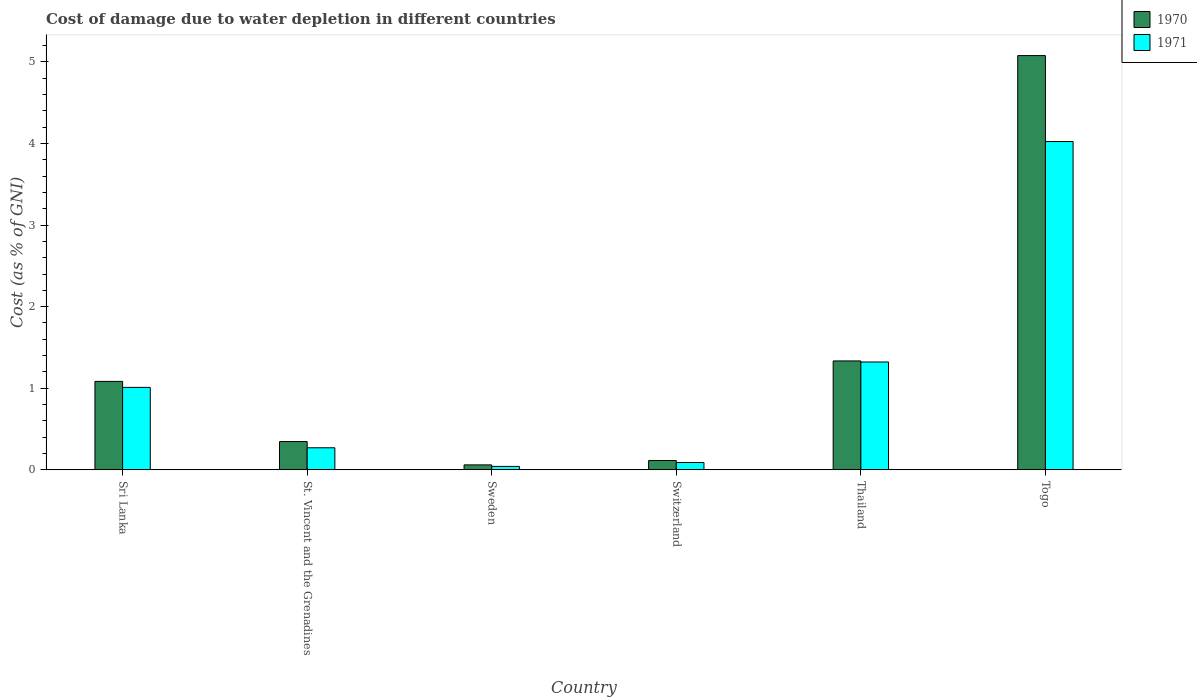Are the number of bars per tick equal to the number of legend labels?
Provide a short and direct response. Yes. Are the number of bars on each tick of the X-axis equal?
Ensure brevity in your answer.  Yes. What is the label of the 2nd group of bars from the left?
Your answer should be very brief. St. Vincent and the Grenadines. In how many cases, is the number of bars for a given country not equal to the number of legend labels?
Your answer should be compact. 0. What is the cost of damage caused due to water depletion in 1971 in St. Vincent and the Grenadines?
Offer a very short reply. 0.27. Across all countries, what is the maximum cost of damage caused due to water depletion in 1970?
Your response must be concise. 5.08. Across all countries, what is the minimum cost of damage caused due to water depletion in 1970?
Your answer should be very brief. 0.06. In which country was the cost of damage caused due to water depletion in 1971 maximum?
Keep it short and to the point. Togo. In which country was the cost of damage caused due to water depletion in 1971 minimum?
Your response must be concise. Sweden. What is the total cost of damage caused due to water depletion in 1970 in the graph?
Your answer should be compact. 8.02. What is the difference between the cost of damage caused due to water depletion in 1971 in Sri Lanka and that in St. Vincent and the Grenadines?
Offer a very short reply. 0.74. What is the difference between the cost of damage caused due to water depletion in 1971 in Thailand and the cost of damage caused due to water depletion in 1970 in St. Vincent and the Grenadines?
Give a very brief answer. 0.98. What is the average cost of damage caused due to water depletion in 1971 per country?
Ensure brevity in your answer.  1.13. What is the difference between the cost of damage caused due to water depletion of/in 1971 and cost of damage caused due to water depletion of/in 1970 in Togo?
Make the answer very short. -1.05. What is the ratio of the cost of damage caused due to water depletion in 1971 in Sri Lanka to that in Thailand?
Make the answer very short. 0.76. Is the cost of damage caused due to water depletion in 1971 in Switzerland less than that in Thailand?
Your response must be concise. Yes. What is the difference between the highest and the second highest cost of damage caused due to water depletion in 1971?
Your answer should be compact. -2.7. What is the difference between the highest and the lowest cost of damage caused due to water depletion in 1971?
Keep it short and to the point. 3.98. Is the sum of the cost of damage caused due to water depletion in 1970 in St. Vincent and the Grenadines and Switzerland greater than the maximum cost of damage caused due to water depletion in 1971 across all countries?
Your answer should be very brief. No. How many bars are there?
Offer a terse response. 12. How many countries are there in the graph?
Your answer should be compact. 6. Does the graph contain any zero values?
Offer a very short reply. No. How are the legend labels stacked?
Offer a terse response. Vertical. What is the title of the graph?
Make the answer very short. Cost of damage due to water depletion in different countries. What is the label or title of the X-axis?
Give a very brief answer. Country. What is the label or title of the Y-axis?
Give a very brief answer. Cost (as % of GNI). What is the Cost (as % of GNI) in 1970 in Sri Lanka?
Your response must be concise. 1.08. What is the Cost (as % of GNI) of 1971 in Sri Lanka?
Your answer should be very brief. 1.01. What is the Cost (as % of GNI) in 1970 in St. Vincent and the Grenadines?
Provide a short and direct response. 0.35. What is the Cost (as % of GNI) of 1971 in St. Vincent and the Grenadines?
Your response must be concise. 0.27. What is the Cost (as % of GNI) in 1970 in Sweden?
Provide a succinct answer. 0.06. What is the Cost (as % of GNI) in 1971 in Sweden?
Offer a very short reply. 0.04. What is the Cost (as % of GNI) of 1970 in Switzerland?
Offer a terse response. 0.11. What is the Cost (as % of GNI) in 1971 in Switzerland?
Give a very brief answer. 0.09. What is the Cost (as % of GNI) in 1970 in Thailand?
Your answer should be compact. 1.33. What is the Cost (as % of GNI) in 1971 in Thailand?
Ensure brevity in your answer.  1.32. What is the Cost (as % of GNI) of 1970 in Togo?
Give a very brief answer. 5.08. What is the Cost (as % of GNI) of 1971 in Togo?
Your response must be concise. 4.02. Across all countries, what is the maximum Cost (as % of GNI) of 1970?
Ensure brevity in your answer.  5.08. Across all countries, what is the maximum Cost (as % of GNI) in 1971?
Make the answer very short. 4.02. Across all countries, what is the minimum Cost (as % of GNI) of 1970?
Ensure brevity in your answer.  0.06. Across all countries, what is the minimum Cost (as % of GNI) in 1971?
Make the answer very short. 0.04. What is the total Cost (as % of GNI) of 1970 in the graph?
Make the answer very short. 8.02. What is the total Cost (as % of GNI) of 1971 in the graph?
Keep it short and to the point. 6.76. What is the difference between the Cost (as % of GNI) of 1970 in Sri Lanka and that in St. Vincent and the Grenadines?
Offer a terse response. 0.74. What is the difference between the Cost (as % of GNI) in 1971 in Sri Lanka and that in St. Vincent and the Grenadines?
Give a very brief answer. 0.74. What is the difference between the Cost (as % of GNI) in 1970 in Sri Lanka and that in Sweden?
Give a very brief answer. 1.02. What is the difference between the Cost (as % of GNI) of 1971 in Sri Lanka and that in Sweden?
Provide a succinct answer. 0.97. What is the difference between the Cost (as % of GNI) of 1970 in Sri Lanka and that in Switzerland?
Give a very brief answer. 0.97. What is the difference between the Cost (as % of GNI) in 1971 in Sri Lanka and that in Switzerland?
Offer a very short reply. 0.92. What is the difference between the Cost (as % of GNI) in 1970 in Sri Lanka and that in Thailand?
Provide a short and direct response. -0.25. What is the difference between the Cost (as % of GNI) of 1971 in Sri Lanka and that in Thailand?
Offer a terse response. -0.31. What is the difference between the Cost (as % of GNI) of 1970 in Sri Lanka and that in Togo?
Give a very brief answer. -3.99. What is the difference between the Cost (as % of GNI) of 1971 in Sri Lanka and that in Togo?
Provide a succinct answer. -3.01. What is the difference between the Cost (as % of GNI) of 1970 in St. Vincent and the Grenadines and that in Sweden?
Ensure brevity in your answer.  0.29. What is the difference between the Cost (as % of GNI) in 1971 in St. Vincent and the Grenadines and that in Sweden?
Your answer should be very brief. 0.23. What is the difference between the Cost (as % of GNI) in 1970 in St. Vincent and the Grenadines and that in Switzerland?
Provide a short and direct response. 0.23. What is the difference between the Cost (as % of GNI) in 1971 in St. Vincent and the Grenadines and that in Switzerland?
Make the answer very short. 0.18. What is the difference between the Cost (as % of GNI) of 1970 in St. Vincent and the Grenadines and that in Thailand?
Offer a terse response. -0.99. What is the difference between the Cost (as % of GNI) of 1971 in St. Vincent and the Grenadines and that in Thailand?
Keep it short and to the point. -1.05. What is the difference between the Cost (as % of GNI) in 1970 in St. Vincent and the Grenadines and that in Togo?
Your response must be concise. -4.73. What is the difference between the Cost (as % of GNI) in 1971 in St. Vincent and the Grenadines and that in Togo?
Make the answer very short. -3.75. What is the difference between the Cost (as % of GNI) of 1970 in Sweden and that in Switzerland?
Ensure brevity in your answer.  -0.05. What is the difference between the Cost (as % of GNI) in 1971 in Sweden and that in Switzerland?
Offer a very short reply. -0.05. What is the difference between the Cost (as % of GNI) in 1970 in Sweden and that in Thailand?
Your answer should be very brief. -1.27. What is the difference between the Cost (as % of GNI) in 1971 in Sweden and that in Thailand?
Your response must be concise. -1.28. What is the difference between the Cost (as % of GNI) in 1970 in Sweden and that in Togo?
Offer a very short reply. -5.02. What is the difference between the Cost (as % of GNI) in 1971 in Sweden and that in Togo?
Ensure brevity in your answer.  -3.98. What is the difference between the Cost (as % of GNI) in 1970 in Switzerland and that in Thailand?
Give a very brief answer. -1.22. What is the difference between the Cost (as % of GNI) of 1971 in Switzerland and that in Thailand?
Your answer should be very brief. -1.23. What is the difference between the Cost (as % of GNI) in 1970 in Switzerland and that in Togo?
Offer a terse response. -4.96. What is the difference between the Cost (as % of GNI) in 1971 in Switzerland and that in Togo?
Your response must be concise. -3.93. What is the difference between the Cost (as % of GNI) of 1970 in Thailand and that in Togo?
Your response must be concise. -3.74. What is the difference between the Cost (as % of GNI) of 1971 in Thailand and that in Togo?
Keep it short and to the point. -2.7. What is the difference between the Cost (as % of GNI) of 1970 in Sri Lanka and the Cost (as % of GNI) of 1971 in St. Vincent and the Grenadines?
Provide a short and direct response. 0.81. What is the difference between the Cost (as % of GNI) of 1970 in Sri Lanka and the Cost (as % of GNI) of 1971 in Sweden?
Keep it short and to the point. 1.04. What is the difference between the Cost (as % of GNI) in 1970 in Sri Lanka and the Cost (as % of GNI) in 1971 in Switzerland?
Give a very brief answer. 0.99. What is the difference between the Cost (as % of GNI) of 1970 in Sri Lanka and the Cost (as % of GNI) of 1971 in Thailand?
Provide a short and direct response. -0.24. What is the difference between the Cost (as % of GNI) in 1970 in Sri Lanka and the Cost (as % of GNI) in 1971 in Togo?
Make the answer very short. -2.94. What is the difference between the Cost (as % of GNI) of 1970 in St. Vincent and the Grenadines and the Cost (as % of GNI) of 1971 in Sweden?
Your answer should be very brief. 0.3. What is the difference between the Cost (as % of GNI) in 1970 in St. Vincent and the Grenadines and the Cost (as % of GNI) in 1971 in Switzerland?
Provide a succinct answer. 0.26. What is the difference between the Cost (as % of GNI) in 1970 in St. Vincent and the Grenadines and the Cost (as % of GNI) in 1971 in Thailand?
Your answer should be compact. -0.98. What is the difference between the Cost (as % of GNI) of 1970 in St. Vincent and the Grenadines and the Cost (as % of GNI) of 1971 in Togo?
Provide a succinct answer. -3.68. What is the difference between the Cost (as % of GNI) in 1970 in Sweden and the Cost (as % of GNI) in 1971 in Switzerland?
Offer a terse response. -0.03. What is the difference between the Cost (as % of GNI) in 1970 in Sweden and the Cost (as % of GNI) in 1971 in Thailand?
Offer a terse response. -1.26. What is the difference between the Cost (as % of GNI) of 1970 in Sweden and the Cost (as % of GNI) of 1971 in Togo?
Give a very brief answer. -3.96. What is the difference between the Cost (as % of GNI) of 1970 in Switzerland and the Cost (as % of GNI) of 1971 in Thailand?
Make the answer very short. -1.21. What is the difference between the Cost (as % of GNI) of 1970 in Switzerland and the Cost (as % of GNI) of 1971 in Togo?
Your response must be concise. -3.91. What is the difference between the Cost (as % of GNI) of 1970 in Thailand and the Cost (as % of GNI) of 1971 in Togo?
Keep it short and to the point. -2.69. What is the average Cost (as % of GNI) in 1970 per country?
Offer a very short reply. 1.34. What is the average Cost (as % of GNI) in 1971 per country?
Your response must be concise. 1.13. What is the difference between the Cost (as % of GNI) in 1970 and Cost (as % of GNI) in 1971 in Sri Lanka?
Provide a short and direct response. 0.07. What is the difference between the Cost (as % of GNI) in 1970 and Cost (as % of GNI) in 1971 in St. Vincent and the Grenadines?
Ensure brevity in your answer.  0.08. What is the difference between the Cost (as % of GNI) in 1970 and Cost (as % of GNI) in 1971 in Sweden?
Give a very brief answer. 0.02. What is the difference between the Cost (as % of GNI) in 1970 and Cost (as % of GNI) in 1971 in Switzerland?
Provide a short and direct response. 0.02. What is the difference between the Cost (as % of GNI) of 1970 and Cost (as % of GNI) of 1971 in Thailand?
Provide a succinct answer. 0.01. What is the difference between the Cost (as % of GNI) of 1970 and Cost (as % of GNI) of 1971 in Togo?
Your response must be concise. 1.05. What is the ratio of the Cost (as % of GNI) of 1970 in Sri Lanka to that in St. Vincent and the Grenadines?
Ensure brevity in your answer.  3.13. What is the ratio of the Cost (as % of GNI) in 1971 in Sri Lanka to that in St. Vincent and the Grenadines?
Offer a very short reply. 3.74. What is the ratio of the Cost (as % of GNI) of 1970 in Sri Lanka to that in Sweden?
Your response must be concise. 17.98. What is the ratio of the Cost (as % of GNI) in 1971 in Sri Lanka to that in Sweden?
Provide a short and direct response. 24.24. What is the ratio of the Cost (as % of GNI) of 1970 in Sri Lanka to that in Switzerland?
Your answer should be very brief. 9.55. What is the ratio of the Cost (as % of GNI) of 1971 in Sri Lanka to that in Switzerland?
Provide a succinct answer. 11.33. What is the ratio of the Cost (as % of GNI) in 1970 in Sri Lanka to that in Thailand?
Provide a succinct answer. 0.81. What is the ratio of the Cost (as % of GNI) in 1971 in Sri Lanka to that in Thailand?
Your response must be concise. 0.76. What is the ratio of the Cost (as % of GNI) in 1970 in Sri Lanka to that in Togo?
Offer a very short reply. 0.21. What is the ratio of the Cost (as % of GNI) of 1971 in Sri Lanka to that in Togo?
Ensure brevity in your answer.  0.25. What is the ratio of the Cost (as % of GNI) in 1970 in St. Vincent and the Grenadines to that in Sweden?
Ensure brevity in your answer.  5.75. What is the ratio of the Cost (as % of GNI) of 1971 in St. Vincent and the Grenadines to that in Sweden?
Give a very brief answer. 6.48. What is the ratio of the Cost (as % of GNI) in 1970 in St. Vincent and the Grenadines to that in Switzerland?
Your answer should be compact. 3.05. What is the ratio of the Cost (as % of GNI) in 1971 in St. Vincent and the Grenadines to that in Switzerland?
Offer a very short reply. 3.03. What is the ratio of the Cost (as % of GNI) of 1970 in St. Vincent and the Grenadines to that in Thailand?
Your response must be concise. 0.26. What is the ratio of the Cost (as % of GNI) in 1971 in St. Vincent and the Grenadines to that in Thailand?
Offer a terse response. 0.2. What is the ratio of the Cost (as % of GNI) in 1970 in St. Vincent and the Grenadines to that in Togo?
Your answer should be very brief. 0.07. What is the ratio of the Cost (as % of GNI) in 1971 in St. Vincent and the Grenadines to that in Togo?
Provide a succinct answer. 0.07. What is the ratio of the Cost (as % of GNI) of 1970 in Sweden to that in Switzerland?
Provide a succinct answer. 0.53. What is the ratio of the Cost (as % of GNI) in 1971 in Sweden to that in Switzerland?
Make the answer very short. 0.47. What is the ratio of the Cost (as % of GNI) in 1970 in Sweden to that in Thailand?
Your answer should be very brief. 0.05. What is the ratio of the Cost (as % of GNI) in 1971 in Sweden to that in Thailand?
Give a very brief answer. 0.03. What is the ratio of the Cost (as % of GNI) of 1970 in Sweden to that in Togo?
Your answer should be very brief. 0.01. What is the ratio of the Cost (as % of GNI) of 1971 in Sweden to that in Togo?
Provide a short and direct response. 0.01. What is the ratio of the Cost (as % of GNI) in 1970 in Switzerland to that in Thailand?
Ensure brevity in your answer.  0.09. What is the ratio of the Cost (as % of GNI) in 1971 in Switzerland to that in Thailand?
Ensure brevity in your answer.  0.07. What is the ratio of the Cost (as % of GNI) of 1970 in Switzerland to that in Togo?
Keep it short and to the point. 0.02. What is the ratio of the Cost (as % of GNI) of 1971 in Switzerland to that in Togo?
Provide a succinct answer. 0.02. What is the ratio of the Cost (as % of GNI) in 1970 in Thailand to that in Togo?
Offer a terse response. 0.26. What is the ratio of the Cost (as % of GNI) in 1971 in Thailand to that in Togo?
Give a very brief answer. 0.33. What is the difference between the highest and the second highest Cost (as % of GNI) in 1970?
Keep it short and to the point. 3.74. What is the difference between the highest and the second highest Cost (as % of GNI) of 1971?
Give a very brief answer. 2.7. What is the difference between the highest and the lowest Cost (as % of GNI) of 1970?
Keep it short and to the point. 5.02. What is the difference between the highest and the lowest Cost (as % of GNI) in 1971?
Offer a very short reply. 3.98. 